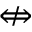<formula> <loc_0><loc_0><loc_500><loc_500>\ n L e f t r i g h t a r r o w</formula> 